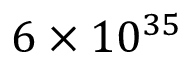Convert formula to latex. <formula><loc_0><loc_0><loc_500><loc_500>6 \times 1 0 ^ { 3 5 }</formula> 